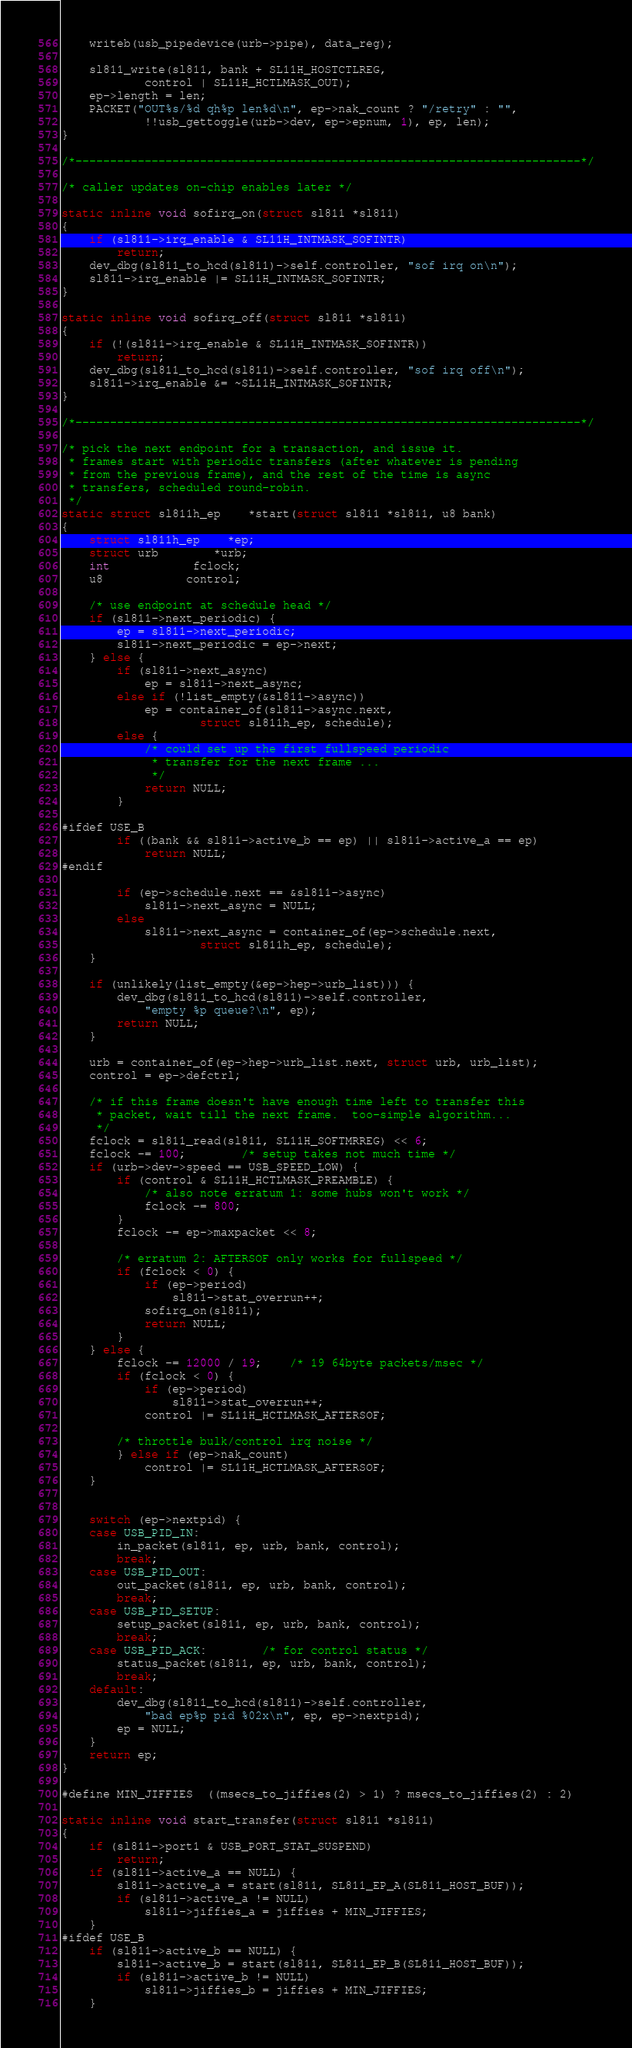<code> <loc_0><loc_0><loc_500><loc_500><_C_>	writeb(usb_pipedevice(urb->pipe), data_reg);

	sl811_write(sl811, bank + SL11H_HOSTCTLREG,
			control | SL11H_HCTLMASK_OUT);
	ep->length = len;
	PACKET("OUT%s/%d qh%p len%d\n", ep->nak_count ? "/retry" : "",
			!!usb_gettoggle(urb->dev, ep->epnum, 1), ep, len);
}

/*-------------------------------------------------------------------------*/

/* caller updates on-chip enables later */

static inline void sofirq_on(struct sl811 *sl811)
{
	if (sl811->irq_enable & SL11H_INTMASK_SOFINTR)
		return;
	dev_dbg(sl811_to_hcd(sl811)->self.controller, "sof irq on\n");
	sl811->irq_enable |= SL11H_INTMASK_SOFINTR;
}

static inline void sofirq_off(struct sl811 *sl811)
{
	if (!(sl811->irq_enable & SL11H_INTMASK_SOFINTR))
		return;
	dev_dbg(sl811_to_hcd(sl811)->self.controller, "sof irq off\n");
	sl811->irq_enable &= ~SL11H_INTMASK_SOFINTR;
}

/*-------------------------------------------------------------------------*/

/* pick the next endpoint for a transaction, and issue it.
 * frames start with periodic transfers (after whatever is pending
 * from the previous frame), and the rest of the time is async
 * transfers, scheduled round-robin.
 */
static struct sl811h_ep	*start(struct sl811 *sl811, u8 bank)
{
	struct sl811h_ep	*ep;
	struct urb		*urb;
	int			fclock;
	u8			control;

	/* use endpoint at schedule head */
	if (sl811->next_periodic) {
		ep = sl811->next_periodic;
		sl811->next_periodic = ep->next;
	} else {
		if (sl811->next_async)
			ep = sl811->next_async;
		else if (!list_empty(&sl811->async))
			ep = container_of(sl811->async.next,
					struct sl811h_ep, schedule);
		else {
			/* could set up the first fullspeed periodic
			 * transfer for the next frame ...
			 */
			return NULL;
		}

#ifdef USE_B
		if ((bank && sl811->active_b == ep) || sl811->active_a == ep)
			return NULL;
#endif

		if (ep->schedule.next == &sl811->async)
			sl811->next_async = NULL;
		else
			sl811->next_async = container_of(ep->schedule.next,
					struct sl811h_ep, schedule);
	}

	if (unlikely(list_empty(&ep->hep->urb_list))) {
		dev_dbg(sl811_to_hcd(sl811)->self.controller,
			"empty %p queue?\n", ep);
		return NULL;
	}

	urb = container_of(ep->hep->urb_list.next, struct urb, urb_list);
	control = ep->defctrl;

	/* if this frame doesn't have enough time left to transfer this
	 * packet, wait till the next frame.  too-simple algorithm...
	 */
	fclock = sl811_read(sl811, SL11H_SOFTMRREG) << 6;
	fclock -= 100;		/* setup takes not much time */
	if (urb->dev->speed == USB_SPEED_LOW) {
		if (control & SL11H_HCTLMASK_PREAMBLE) {
			/* also note erratum 1: some hubs won't work */
			fclock -= 800;
		}
		fclock -= ep->maxpacket << 8;

		/* erratum 2: AFTERSOF only works for fullspeed */
		if (fclock < 0) {
			if (ep->period)
				sl811->stat_overrun++;
			sofirq_on(sl811);
			return NULL;
		}
	} else {
		fclock -= 12000 / 19;	/* 19 64byte packets/msec */
		if (fclock < 0) {
			if (ep->period)
				sl811->stat_overrun++;
			control |= SL11H_HCTLMASK_AFTERSOF;

		/* throttle bulk/control irq noise */
		} else if (ep->nak_count)
			control |= SL11H_HCTLMASK_AFTERSOF;
	}


	switch (ep->nextpid) {
	case USB_PID_IN:
		in_packet(sl811, ep, urb, bank, control);
		break;
	case USB_PID_OUT:
		out_packet(sl811, ep, urb, bank, control);
		break;
	case USB_PID_SETUP:
		setup_packet(sl811, ep, urb, bank, control);
		break;
	case USB_PID_ACK:		/* for control status */
		status_packet(sl811, ep, urb, bank, control);
		break;
	default:
		dev_dbg(sl811_to_hcd(sl811)->self.controller,
			"bad ep%p pid %02x\n", ep, ep->nextpid);
		ep = NULL;
	}
	return ep;
}

#define MIN_JIFFIES	((msecs_to_jiffies(2) > 1) ? msecs_to_jiffies(2) : 2)

static inline void start_transfer(struct sl811 *sl811)
{
	if (sl811->port1 & USB_PORT_STAT_SUSPEND)
		return;
	if (sl811->active_a == NULL) {
		sl811->active_a = start(sl811, SL811_EP_A(SL811_HOST_BUF));
		if (sl811->active_a != NULL)
			sl811->jiffies_a = jiffies + MIN_JIFFIES;
	}
#ifdef USE_B
	if (sl811->active_b == NULL) {
		sl811->active_b = start(sl811, SL811_EP_B(SL811_HOST_BUF));
		if (sl811->active_b != NULL)
			sl811->jiffies_b = jiffies + MIN_JIFFIES;
	}</code> 